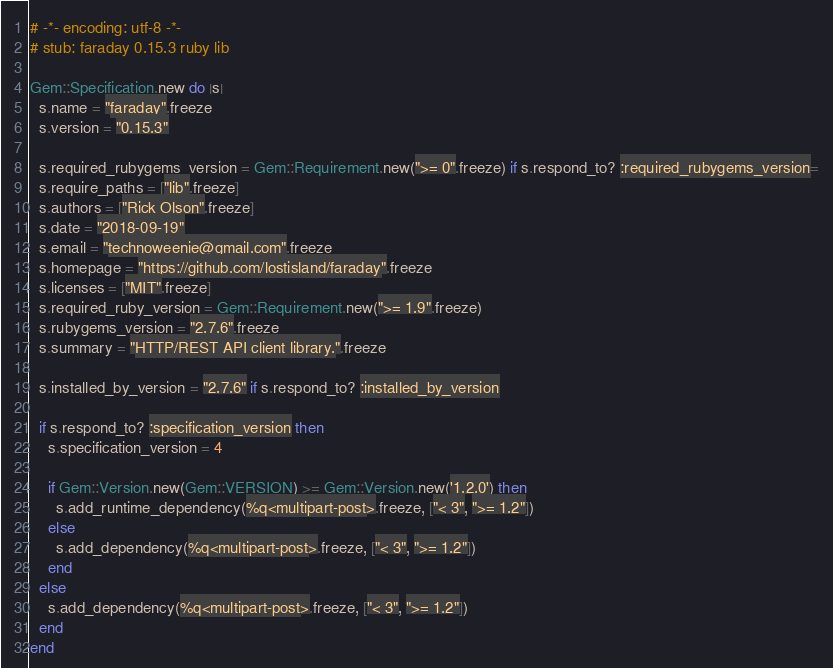Convert code to text. <code><loc_0><loc_0><loc_500><loc_500><_Ruby_># -*- encoding: utf-8 -*-
# stub: faraday 0.15.3 ruby lib

Gem::Specification.new do |s|
  s.name = "faraday".freeze
  s.version = "0.15.3"

  s.required_rubygems_version = Gem::Requirement.new(">= 0".freeze) if s.respond_to? :required_rubygems_version=
  s.require_paths = ["lib".freeze]
  s.authors = ["Rick Olson".freeze]
  s.date = "2018-09-19"
  s.email = "technoweenie@gmail.com".freeze
  s.homepage = "https://github.com/lostisland/faraday".freeze
  s.licenses = ["MIT".freeze]
  s.required_ruby_version = Gem::Requirement.new(">= 1.9".freeze)
  s.rubygems_version = "2.7.6".freeze
  s.summary = "HTTP/REST API client library.".freeze

  s.installed_by_version = "2.7.6" if s.respond_to? :installed_by_version

  if s.respond_to? :specification_version then
    s.specification_version = 4

    if Gem::Version.new(Gem::VERSION) >= Gem::Version.new('1.2.0') then
      s.add_runtime_dependency(%q<multipart-post>.freeze, ["< 3", ">= 1.2"])
    else
      s.add_dependency(%q<multipart-post>.freeze, ["< 3", ">= 1.2"])
    end
  else
    s.add_dependency(%q<multipart-post>.freeze, ["< 3", ">= 1.2"])
  end
end
</code> 